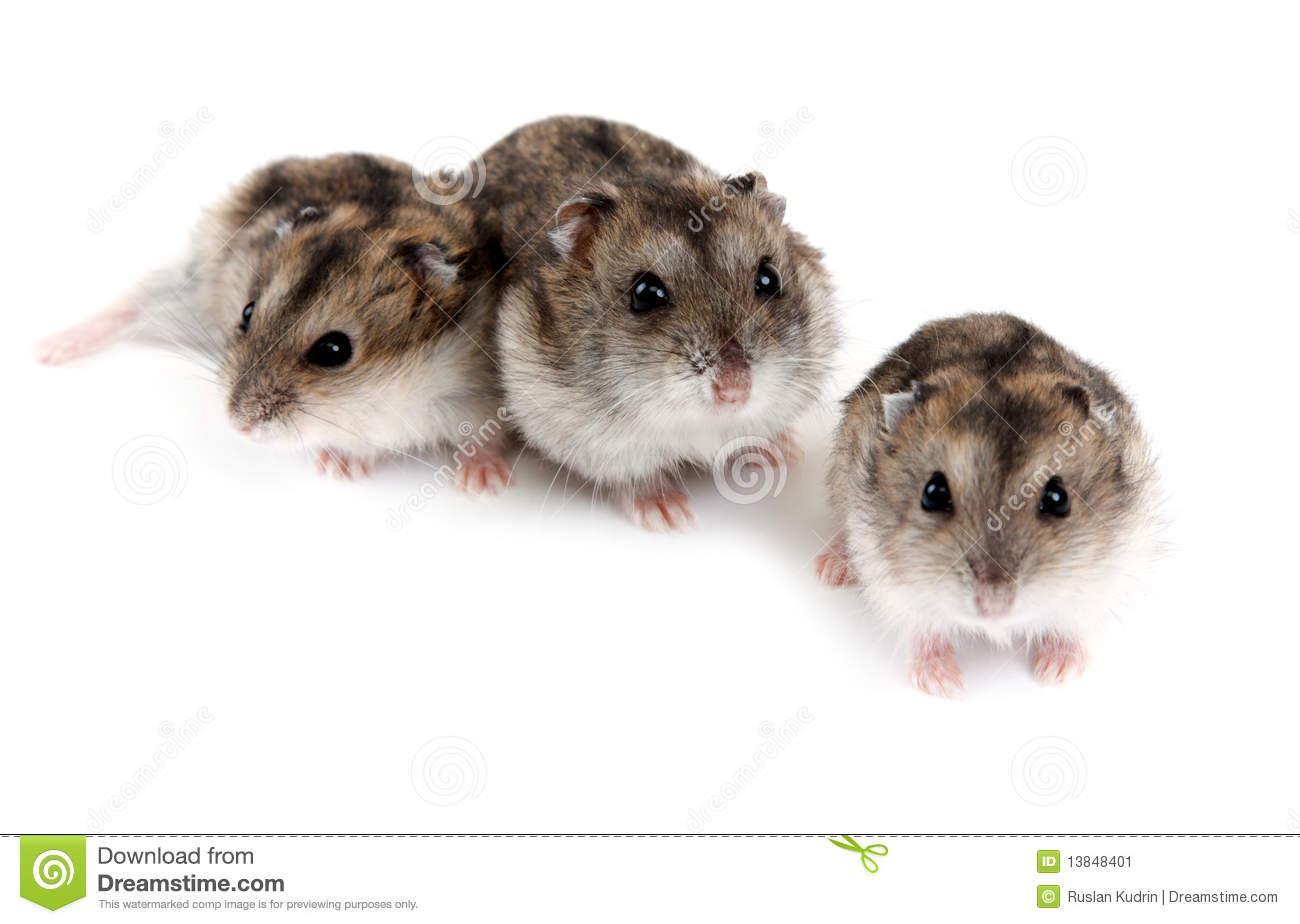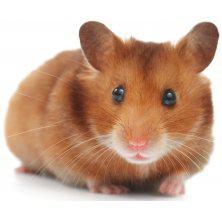The first image is the image on the left, the second image is the image on the right. Evaluate the accuracy of this statement regarding the images: "There is a mouse that is all white in color.". Is it true? Answer yes or no. No. The first image is the image on the left, the second image is the image on the right. Considering the images on both sides, is "the animal in the image on the right is on all fours" valid? Answer yes or no. Yes. 